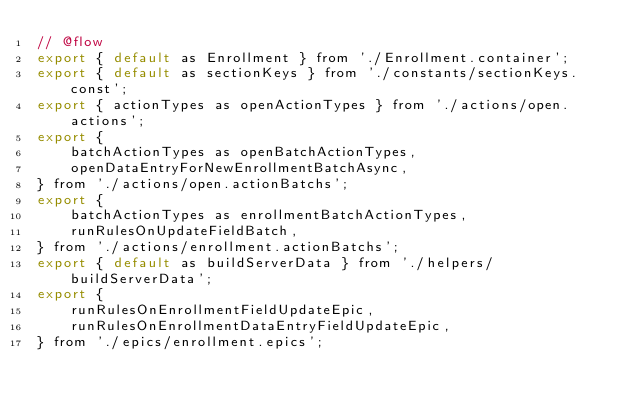Convert code to text. <code><loc_0><loc_0><loc_500><loc_500><_JavaScript_>// @flow
export { default as Enrollment } from './Enrollment.container';
export { default as sectionKeys } from './constants/sectionKeys.const';
export { actionTypes as openActionTypes } from './actions/open.actions';
export {
    batchActionTypes as openBatchActionTypes,
    openDataEntryForNewEnrollmentBatchAsync,
} from './actions/open.actionBatchs';
export {
    batchActionTypes as enrollmentBatchActionTypes,
    runRulesOnUpdateFieldBatch,
} from './actions/enrollment.actionBatchs';
export { default as buildServerData } from './helpers/buildServerData';
export {
    runRulesOnEnrollmentFieldUpdateEpic,
    runRulesOnEnrollmentDataEntryFieldUpdateEpic,
} from './epics/enrollment.epics';
</code> 